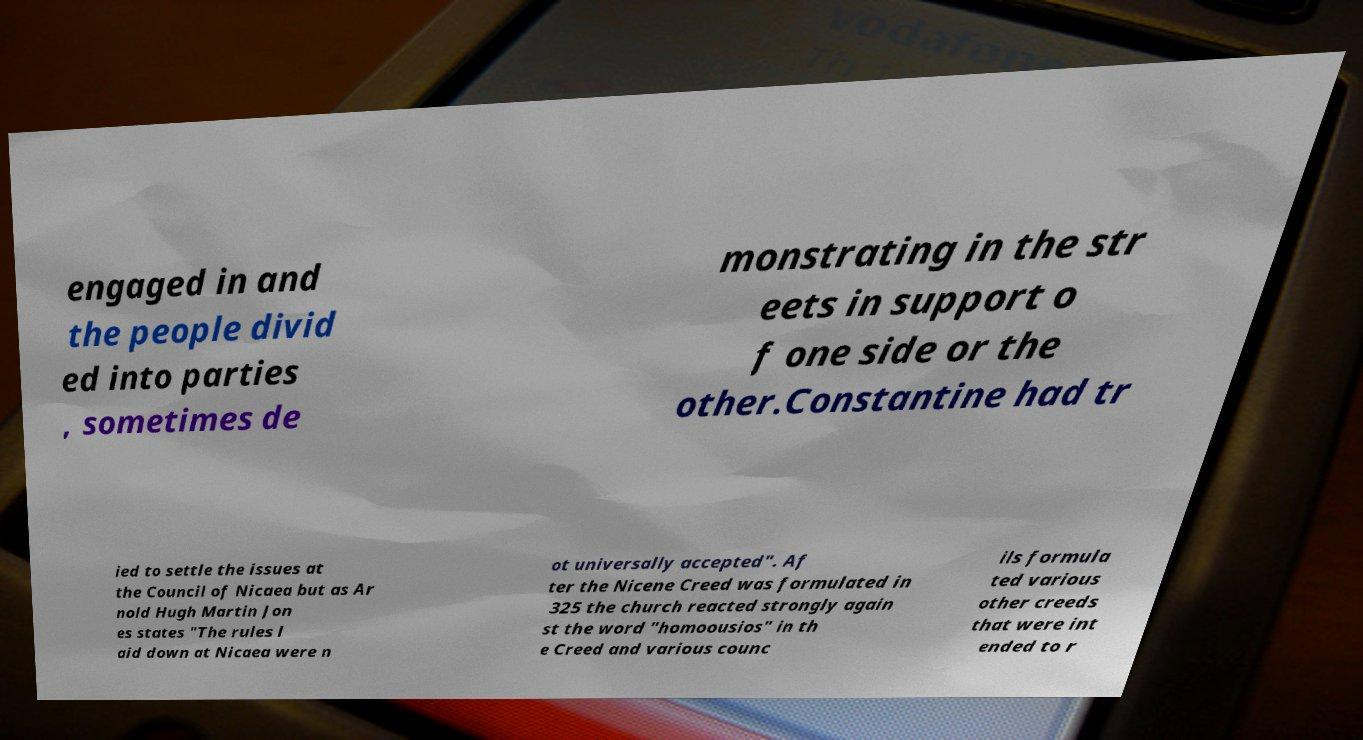Please identify and transcribe the text found in this image. engaged in and the people divid ed into parties , sometimes de monstrating in the str eets in support o f one side or the other.Constantine had tr ied to settle the issues at the Council of Nicaea but as Ar nold Hugh Martin Jon es states "The rules l aid down at Nicaea were n ot universally accepted". Af ter the Nicene Creed was formulated in 325 the church reacted strongly again st the word "homoousios" in th e Creed and various counc ils formula ted various other creeds that were int ended to r 